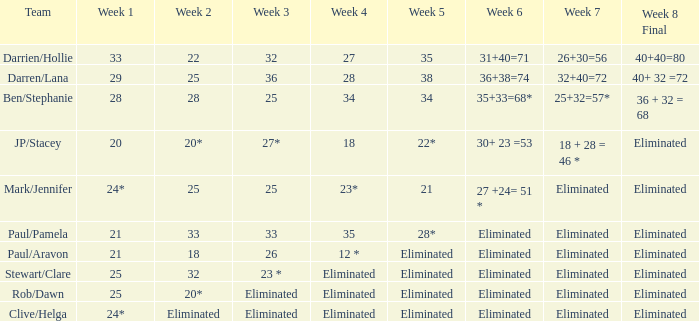Identify the week 3 out of the 36 weeks. 29.0. 